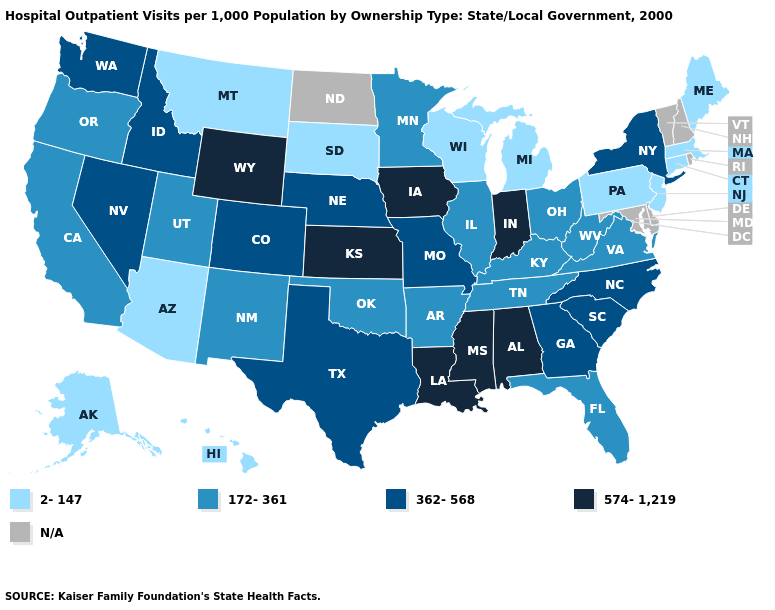Name the states that have a value in the range 172-361?
Answer briefly. Arkansas, California, Florida, Illinois, Kentucky, Minnesota, New Mexico, Ohio, Oklahoma, Oregon, Tennessee, Utah, Virginia, West Virginia. Name the states that have a value in the range 2-147?
Concise answer only. Alaska, Arizona, Connecticut, Hawaii, Maine, Massachusetts, Michigan, Montana, New Jersey, Pennsylvania, South Dakota, Wisconsin. What is the value of Pennsylvania?
Keep it brief. 2-147. How many symbols are there in the legend?
Concise answer only. 5. Does Massachusetts have the lowest value in the Northeast?
Keep it brief. Yes. Which states have the lowest value in the West?
Answer briefly. Alaska, Arizona, Hawaii, Montana. Does Pennsylvania have the lowest value in the USA?
Write a very short answer. Yes. What is the value of New York?
Short answer required. 362-568. Name the states that have a value in the range 172-361?
Be succinct. Arkansas, California, Florida, Illinois, Kentucky, Minnesota, New Mexico, Ohio, Oklahoma, Oregon, Tennessee, Utah, Virginia, West Virginia. What is the highest value in the USA?
Be succinct. 574-1,219. Does Colorado have the lowest value in the West?
Quick response, please. No. Does Illinois have the lowest value in the MidWest?
Be succinct. No. Does Nebraska have the highest value in the USA?
Short answer required. No. Name the states that have a value in the range 574-1,219?
Give a very brief answer. Alabama, Indiana, Iowa, Kansas, Louisiana, Mississippi, Wyoming. 